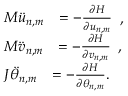Convert formula to latex. <formula><loc_0><loc_0><loc_500><loc_500>\begin{array} { r l } & { \begin{array} { r l } { M \ddot { u } _ { n , m } } & { = - \frac { \partial H } { \partial u _ { n , m } } } \end{array} , } \\ & { \begin{array} { r l } { M \ddot { v } _ { n , m } } & { = - \frac { \partial H } { \partial v _ { n , m } } } \end{array} , } \\ & { \begin{array} { r l } { J \ddot { \theta } _ { n , m } } & { = - \frac { \partial H } { \partial \theta _ { n , m } } . } \end{array} } \end{array}</formula> 